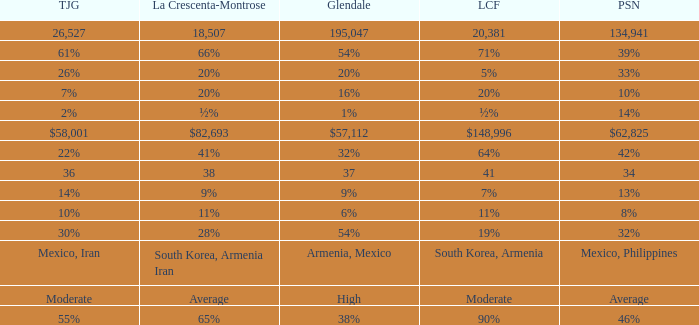Would you be able to parse every entry in this table? {'header': ['TJG', 'La Crescenta-Montrose', 'Glendale', 'LCF', 'PSN'], 'rows': [['26,527', '18,507', '195,047', '20,381', '134,941'], ['61%', '66%', '54%', '71%', '39%'], ['26%', '20%', '20%', '5%', '33%'], ['7%', '20%', '16%', '20%', '10%'], ['2%', '½%', '1%', '½%', '14%'], ['$58,001', '$82,693', '$57,112', '$148,996', '$62,825'], ['22%', '41%', '32%', '64%', '42%'], ['36', '38', '37', '41', '34'], ['14%', '9%', '9%', '7%', '13%'], ['10%', '11%', '6%', '11%', '8%'], ['30%', '28%', '54%', '19%', '32%'], ['Mexico, Iran', 'South Korea, Armenia Iran', 'Armenia, Mexico', 'South Korea, Armenia', 'Mexico, Philippines'], ['Moderate', 'Average', 'High', 'Moderate', 'Average'], ['55%', '65%', '38%', '90%', '46%']]} What is the figure for Pasadena when Tujunga is 36? 34.0. 